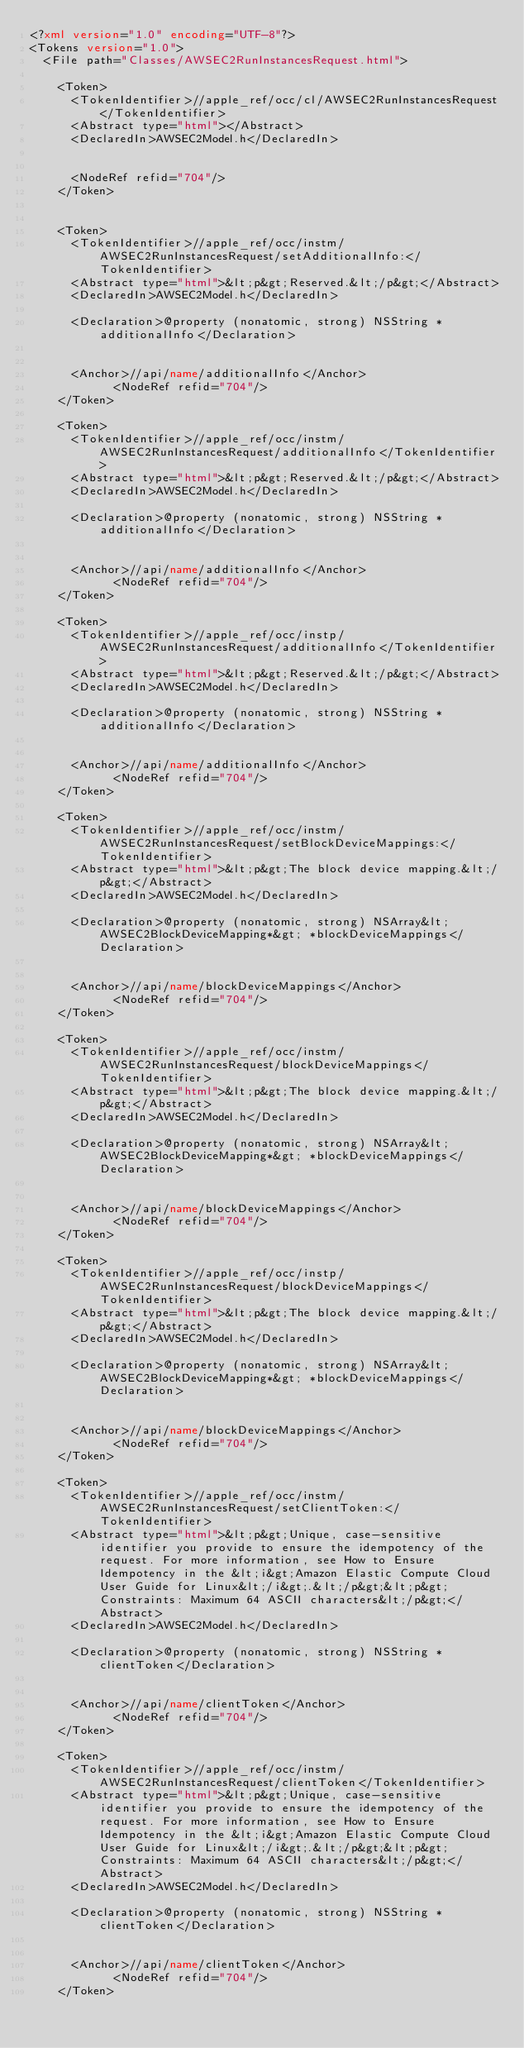Convert code to text. <code><loc_0><loc_0><loc_500><loc_500><_XML_><?xml version="1.0" encoding="UTF-8"?>
<Tokens version="1.0">
	<File path="Classes/AWSEC2RunInstancesRequest.html">
		
		<Token>
			<TokenIdentifier>//apple_ref/occ/cl/AWSEC2RunInstancesRequest</TokenIdentifier>
			<Abstract type="html"></Abstract>
			<DeclaredIn>AWSEC2Model.h</DeclaredIn>
            
			
			<NodeRef refid="704"/>
		</Token>
		
		
		<Token>
			<TokenIdentifier>//apple_ref/occ/instm/AWSEC2RunInstancesRequest/setAdditionalInfo:</TokenIdentifier>
			<Abstract type="html">&lt;p&gt;Reserved.&lt;/p&gt;</Abstract>
			<DeclaredIn>AWSEC2Model.h</DeclaredIn>
			
			<Declaration>@property (nonatomic, strong) NSString *additionalInfo</Declaration>
			
			
			<Anchor>//api/name/additionalInfo</Anchor>
            <NodeRef refid="704"/>
		</Token>
		
		<Token>
			<TokenIdentifier>//apple_ref/occ/instm/AWSEC2RunInstancesRequest/additionalInfo</TokenIdentifier>
			<Abstract type="html">&lt;p&gt;Reserved.&lt;/p&gt;</Abstract>
			<DeclaredIn>AWSEC2Model.h</DeclaredIn>
			
			<Declaration>@property (nonatomic, strong) NSString *additionalInfo</Declaration>
			
			
			<Anchor>//api/name/additionalInfo</Anchor>
            <NodeRef refid="704"/>
		</Token>
		
		<Token>
			<TokenIdentifier>//apple_ref/occ/instp/AWSEC2RunInstancesRequest/additionalInfo</TokenIdentifier>
			<Abstract type="html">&lt;p&gt;Reserved.&lt;/p&gt;</Abstract>
			<DeclaredIn>AWSEC2Model.h</DeclaredIn>
			
			<Declaration>@property (nonatomic, strong) NSString *additionalInfo</Declaration>
			
			
			<Anchor>//api/name/additionalInfo</Anchor>
            <NodeRef refid="704"/>
		</Token>
		
		<Token>
			<TokenIdentifier>//apple_ref/occ/instm/AWSEC2RunInstancesRequest/setBlockDeviceMappings:</TokenIdentifier>
			<Abstract type="html">&lt;p&gt;The block device mapping.&lt;/p&gt;</Abstract>
			<DeclaredIn>AWSEC2Model.h</DeclaredIn>
			
			<Declaration>@property (nonatomic, strong) NSArray&lt;AWSEC2BlockDeviceMapping*&gt; *blockDeviceMappings</Declaration>
			
			
			<Anchor>//api/name/blockDeviceMappings</Anchor>
            <NodeRef refid="704"/>
		</Token>
		
		<Token>
			<TokenIdentifier>//apple_ref/occ/instm/AWSEC2RunInstancesRequest/blockDeviceMappings</TokenIdentifier>
			<Abstract type="html">&lt;p&gt;The block device mapping.&lt;/p&gt;</Abstract>
			<DeclaredIn>AWSEC2Model.h</DeclaredIn>
			
			<Declaration>@property (nonatomic, strong) NSArray&lt;AWSEC2BlockDeviceMapping*&gt; *blockDeviceMappings</Declaration>
			
			
			<Anchor>//api/name/blockDeviceMappings</Anchor>
            <NodeRef refid="704"/>
		</Token>
		
		<Token>
			<TokenIdentifier>//apple_ref/occ/instp/AWSEC2RunInstancesRequest/blockDeviceMappings</TokenIdentifier>
			<Abstract type="html">&lt;p&gt;The block device mapping.&lt;/p&gt;</Abstract>
			<DeclaredIn>AWSEC2Model.h</DeclaredIn>
			
			<Declaration>@property (nonatomic, strong) NSArray&lt;AWSEC2BlockDeviceMapping*&gt; *blockDeviceMappings</Declaration>
			
			
			<Anchor>//api/name/blockDeviceMappings</Anchor>
            <NodeRef refid="704"/>
		</Token>
		
		<Token>
			<TokenIdentifier>//apple_ref/occ/instm/AWSEC2RunInstancesRequest/setClientToken:</TokenIdentifier>
			<Abstract type="html">&lt;p&gt;Unique, case-sensitive identifier you provide to ensure the idempotency of the request. For more information, see How to Ensure Idempotency in the &lt;i&gt;Amazon Elastic Compute Cloud User Guide for Linux&lt;/i&gt;.&lt;/p&gt;&lt;p&gt;Constraints: Maximum 64 ASCII characters&lt;/p&gt;</Abstract>
			<DeclaredIn>AWSEC2Model.h</DeclaredIn>
			
			<Declaration>@property (nonatomic, strong) NSString *clientToken</Declaration>
			
			
			<Anchor>//api/name/clientToken</Anchor>
            <NodeRef refid="704"/>
		</Token>
		
		<Token>
			<TokenIdentifier>//apple_ref/occ/instm/AWSEC2RunInstancesRequest/clientToken</TokenIdentifier>
			<Abstract type="html">&lt;p&gt;Unique, case-sensitive identifier you provide to ensure the idempotency of the request. For more information, see How to Ensure Idempotency in the &lt;i&gt;Amazon Elastic Compute Cloud User Guide for Linux&lt;/i&gt;.&lt;/p&gt;&lt;p&gt;Constraints: Maximum 64 ASCII characters&lt;/p&gt;</Abstract>
			<DeclaredIn>AWSEC2Model.h</DeclaredIn>
			
			<Declaration>@property (nonatomic, strong) NSString *clientToken</Declaration>
			
			
			<Anchor>//api/name/clientToken</Anchor>
            <NodeRef refid="704"/>
		</Token>
		</code> 